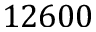<formula> <loc_0><loc_0><loc_500><loc_500>1 2 6 0 0</formula> 